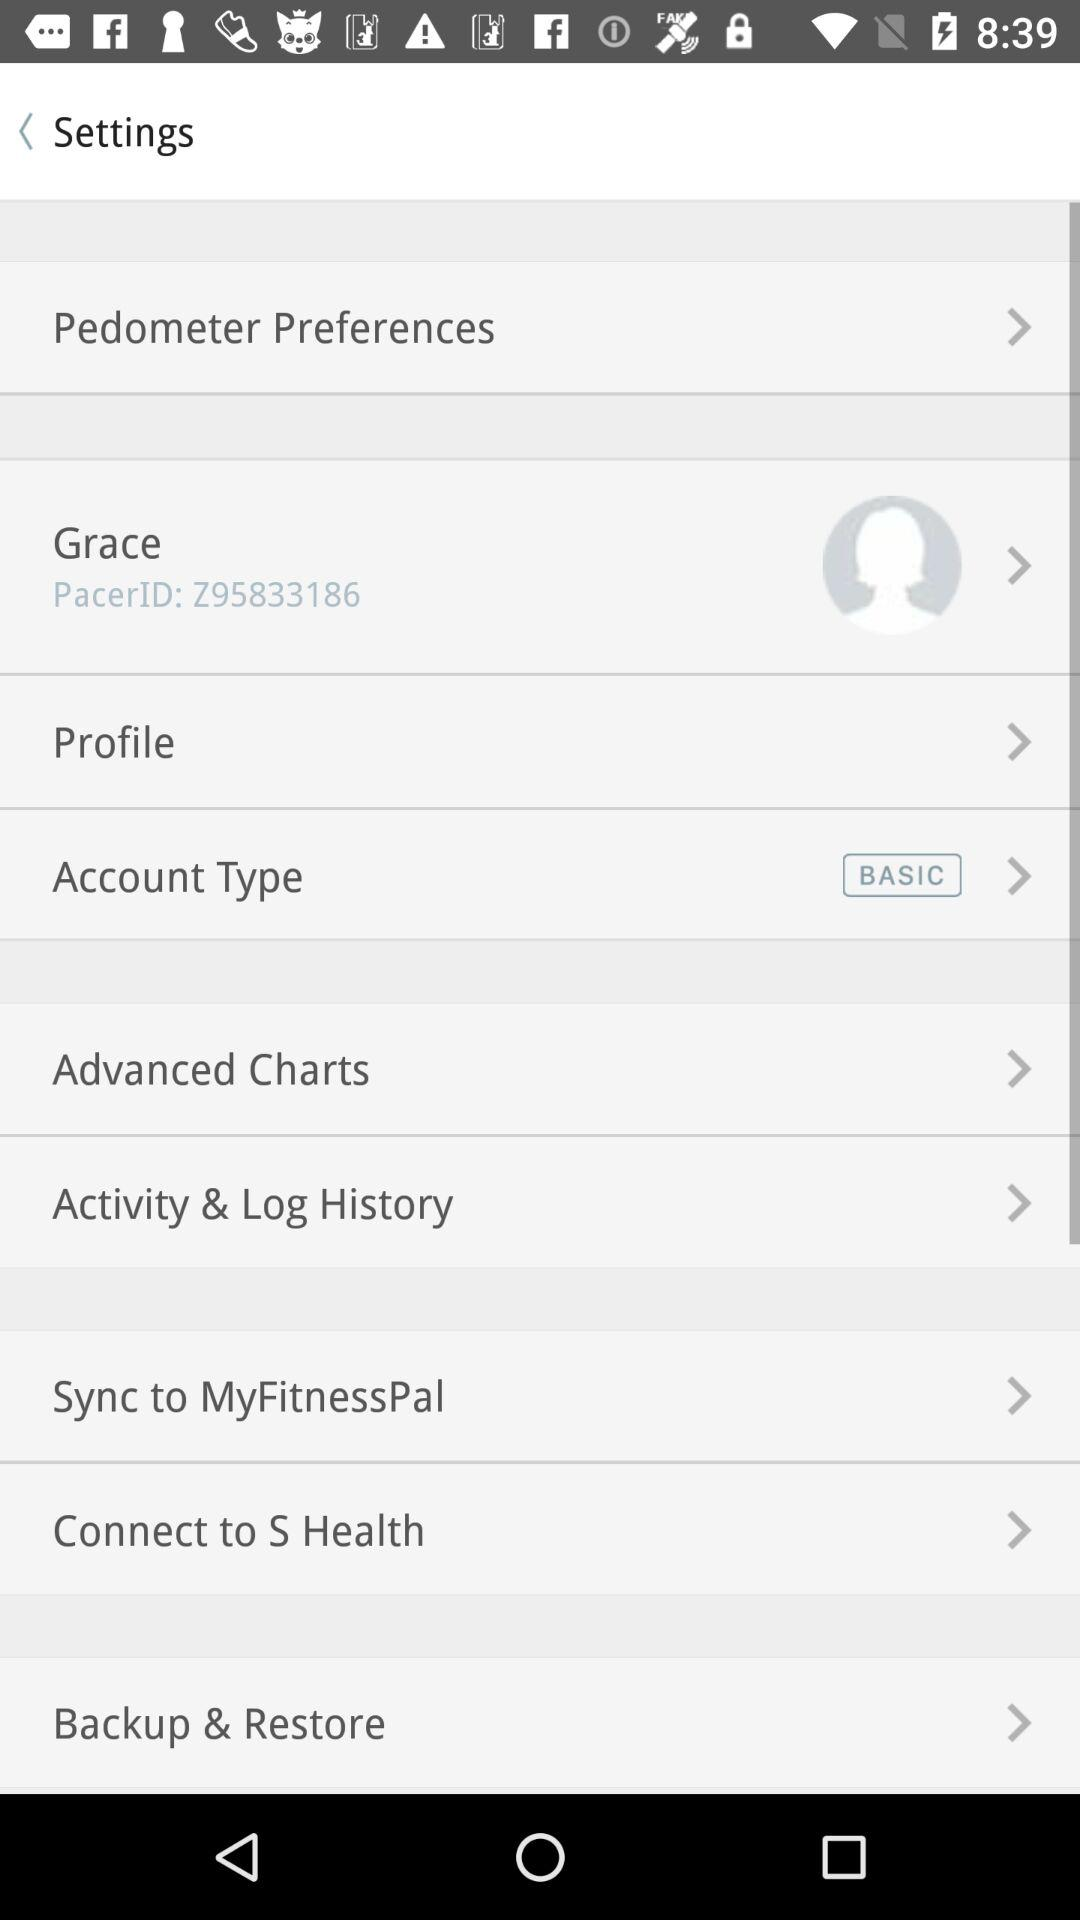What type of account does the user use? The type of account that the user uses is "BASIC". 